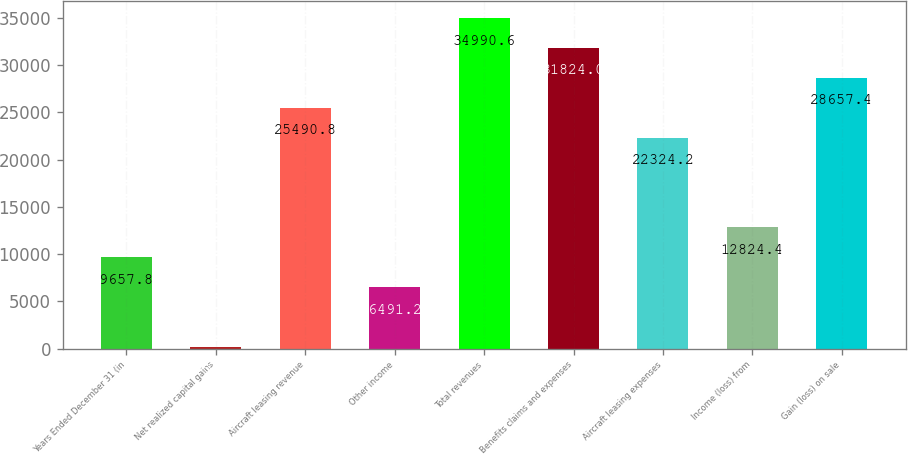Convert chart to OTSL. <chart><loc_0><loc_0><loc_500><loc_500><bar_chart><fcel>Years Ended December 31 (in<fcel>Net realized capital gains<fcel>Aircraft leasing revenue<fcel>Other income<fcel>Total revenues<fcel>Benefits claims and expenses<fcel>Aircraft leasing expenses<fcel>Income (loss) from<fcel>Gain (loss) on sale<nl><fcel>9657.8<fcel>158<fcel>25490.8<fcel>6491.2<fcel>34990.6<fcel>31824<fcel>22324.2<fcel>12824.4<fcel>28657.4<nl></chart> 